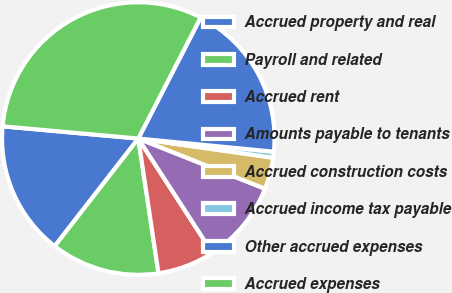Convert chart. <chart><loc_0><loc_0><loc_500><loc_500><pie_chart><fcel>Accrued property and real<fcel>Payroll and related<fcel>Accrued rent<fcel>Amounts payable to tenants<fcel>Accrued construction costs<fcel>Accrued income tax payable<fcel>Other accrued expenses<fcel>Accrued expenses<nl><fcel>15.92%<fcel>12.88%<fcel>6.79%<fcel>9.84%<fcel>3.75%<fcel>0.71%<fcel>18.97%<fcel>31.14%<nl></chart> 